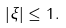<formula> <loc_0><loc_0><loc_500><loc_500>| \xi | \leq 1 .</formula> 